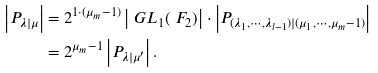Convert formula to latex. <formula><loc_0><loc_0><loc_500><loc_500>\left | P _ { \lambda | \mu } \right | & = 2 ^ { 1 \cdot ( \mu _ { m } - 1 ) } \left | \ G L _ { 1 } ( \ F _ { 2 } ) \right | \cdot \left | P _ { ( \lambda _ { 1 } , \cdots , \lambda _ { l - 1 } ) | ( \mu _ { 1 } , \cdots , \mu _ { m } - 1 ) } \right | \\ & = 2 ^ { \mu _ { m } - 1 } \left | P _ { \lambda | \mu ^ { \prime } } \right | .</formula> 